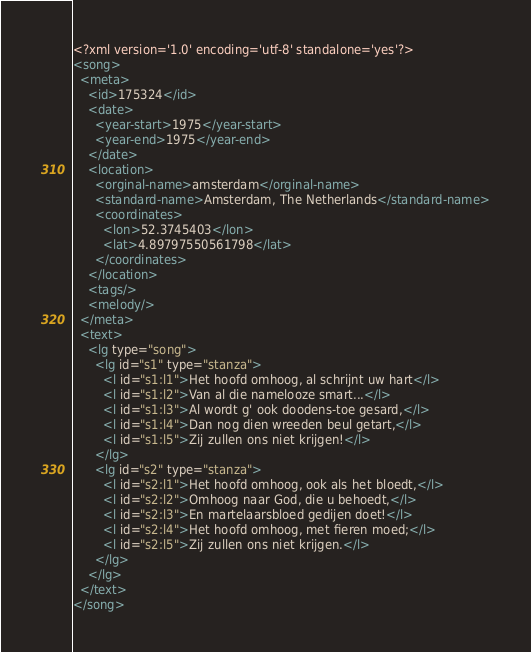Convert code to text. <code><loc_0><loc_0><loc_500><loc_500><_XML_><?xml version='1.0' encoding='utf-8' standalone='yes'?>
<song>
  <meta>
    <id>175324</id>
    <date>
      <year-start>1975</year-start>
      <year-end>1975</year-end>
    </date>
    <location>
      <orginal-name>amsterdam</orginal-name>
      <standard-name>Amsterdam, The Netherlands</standard-name>
      <coordinates>
        <lon>52.3745403</lon>
        <lat>4.89797550561798</lat>
      </coordinates>
    </location>
    <tags/>
    <melody/>
  </meta>
  <text>
    <lg type="song">
      <lg id="s1" type="stanza">
        <l id="s1:l1">Het hoofd omhoog, al schrijnt uw hart</l>
        <l id="s1:l2">Van al die namelooze smart...</l>
        <l id="s1:l3">Al wordt g' ook doodens-toe gesard,</l>
        <l id="s1:l4">Dan nog dien wreeden beul getart,</l>
        <l id="s1:l5">Zij zullen ons niet krijgen!</l>
      </lg>
      <lg id="s2" type="stanza">
        <l id="s2:l1">Het hoofd omhoog, ook als het bloedt,</l>
        <l id="s2:l2">Omhoog naar God, die u behoedt,</l>
        <l id="s2:l3">En martelaarsbloed gedijen doet!</l>
        <l id="s2:l4">Het hoofd omhoog, met fieren moed;</l>
        <l id="s2:l5">Zij zullen ons niet krijgen.</l>
      </lg>
    </lg>
  </text>
</song>
</code> 